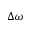Convert formula to latex. <formula><loc_0><loc_0><loc_500><loc_500>\Delta \omega</formula> 